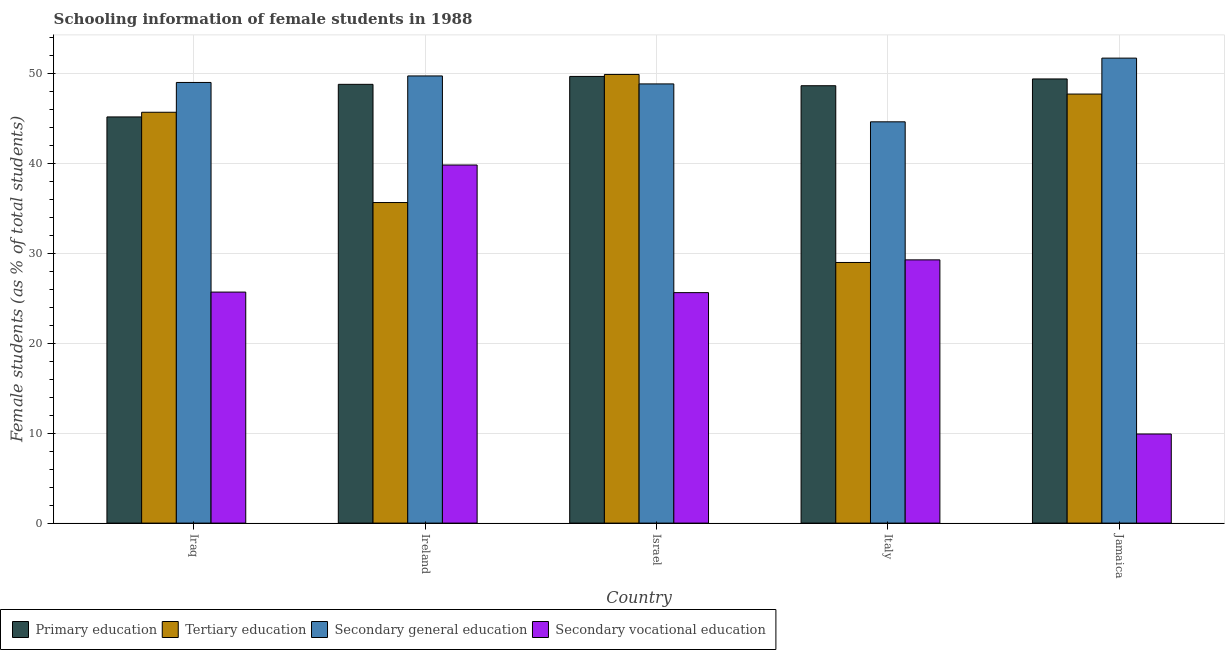How many different coloured bars are there?
Provide a succinct answer. 4. How many groups of bars are there?
Ensure brevity in your answer.  5. Are the number of bars on each tick of the X-axis equal?
Make the answer very short. Yes. How many bars are there on the 3rd tick from the left?
Provide a succinct answer. 4. What is the label of the 5th group of bars from the left?
Offer a very short reply. Jamaica. What is the percentage of female students in primary education in Jamaica?
Keep it short and to the point. 49.35. Across all countries, what is the maximum percentage of female students in secondary education?
Ensure brevity in your answer.  51.67. Across all countries, what is the minimum percentage of female students in secondary vocational education?
Offer a terse response. 9.9. In which country was the percentage of female students in secondary education maximum?
Your answer should be compact. Jamaica. In which country was the percentage of female students in tertiary education minimum?
Give a very brief answer. Italy. What is the total percentage of female students in primary education in the graph?
Make the answer very short. 241.47. What is the difference between the percentage of female students in secondary education in Iraq and that in Israel?
Offer a very short reply. 0.16. What is the difference between the percentage of female students in secondary education in Iraq and the percentage of female students in tertiary education in Jamaica?
Your answer should be very brief. 1.29. What is the average percentage of female students in tertiary education per country?
Offer a terse response. 41.55. What is the difference between the percentage of female students in secondary vocational education and percentage of female students in primary education in Iraq?
Offer a terse response. -19.46. In how many countries, is the percentage of female students in primary education greater than 18 %?
Your answer should be compact. 5. What is the ratio of the percentage of female students in tertiary education in Iraq to that in Jamaica?
Your answer should be very brief. 0.96. Is the percentage of female students in primary education in Iraq less than that in Israel?
Offer a terse response. Yes. Is the difference between the percentage of female students in secondary vocational education in Iraq and Israel greater than the difference between the percentage of female students in secondary education in Iraq and Israel?
Offer a very short reply. No. What is the difference between the highest and the second highest percentage of female students in secondary vocational education?
Ensure brevity in your answer.  10.54. What is the difference between the highest and the lowest percentage of female students in secondary education?
Give a very brief answer. 7.08. Is the sum of the percentage of female students in secondary vocational education in Israel and Italy greater than the maximum percentage of female students in tertiary education across all countries?
Keep it short and to the point. Yes. What does the 3rd bar from the left in Italy represents?
Offer a very short reply. Secondary general education. What does the 3rd bar from the right in Italy represents?
Provide a succinct answer. Tertiary education. Is it the case that in every country, the sum of the percentage of female students in primary education and percentage of female students in tertiary education is greater than the percentage of female students in secondary education?
Provide a short and direct response. Yes. Are all the bars in the graph horizontal?
Your answer should be compact. No. What is the difference between two consecutive major ticks on the Y-axis?
Provide a short and direct response. 10. Are the values on the major ticks of Y-axis written in scientific E-notation?
Keep it short and to the point. No. How many legend labels are there?
Your answer should be very brief. 4. How are the legend labels stacked?
Provide a short and direct response. Horizontal. What is the title of the graph?
Your response must be concise. Schooling information of female students in 1988. Does "Social Insurance" appear as one of the legend labels in the graph?
Provide a short and direct response. No. What is the label or title of the X-axis?
Your answer should be very brief. Country. What is the label or title of the Y-axis?
Provide a succinct answer. Female students (as % of total students). What is the Female students (as % of total students) in Primary education in Iraq?
Keep it short and to the point. 45.13. What is the Female students (as % of total students) in Tertiary education in Iraq?
Offer a terse response. 45.65. What is the Female students (as % of total students) in Secondary general education in Iraq?
Offer a very short reply. 48.96. What is the Female students (as % of total students) of Secondary vocational education in Iraq?
Provide a succinct answer. 25.67. What is the Female students (as % of total students) in Primary education in Ireland?
Give a very brief answer. 48.75. What is the Female students (as % of total students) in Tertiary education in Ireland?
Offer a terse response. 35.62. What is the Female students (as % of total students) of Secondary general education in Ireland?
Keep it short and to the point. 49.69. What is the Female students (as % of total students) in Secondary vocational education in Ireland?
Give a very brief answer. 39.79. What is the Female students (as % of total students) in Primary education in Israel?
Make the answer very short. 49.63. What is the Female students (as % of total students) in Tertiary education in Israel?
Provide a succinct answer. 49.85. What is the Female students (as % of total students) in Secondary general education in Israel?
Make the answer very short. 48.8. What is the Female students (as % of total students) of Secondary vocational education in Israel?
Offer a very short reply. 25.61. What is the Female students (as % of total students) in Primary education in Italy?
Ensure brevity in your answer.  48.6. What is the Female students (as % of total students) in Tertiary education in Italy?
Your response must be concise. 28.96. What is the Female students (as % of total students) of Secondary general education in Italy?
Provide a short and direct response. 44.59. What is the Female students (as % of total students) of Secondary vocational education in Italy?
Keep it short and to the point. 29.25. What is the Female students (as % of total students) in Primary education in Jamaica?
Make the answer very short. 49.35. What is the Female students (as % of total students) in Tertiary education in Jamaica?
Your answer should be compact. 47.67. What is the Female students (as % of total students) of Secondary general education in Jamaica?
Keep it short and to the point. 51.67. What is the Female students (as % of total students) in Secondary vocational education in Jamaica?
Keep it short and to the point. 9.9. Across all countries, what is the maximum Female students (as % of total students) of Primary education?
Your answer should be very brief. 49.63. Across all countries, what is the maximum Female students (as % of total students) of Tertiary education?
Provide a short and direct response. 49.85. Across all countries, what is the maximum Female students (as % of total students) in Secondary general education?
Give a very brief answer. 51.67. Across all countries, what is the maximum Female students (as % of total students) in Secondary vocational education?
Your answer should be very brief. 39.79. Across all countries, what is the minimum Female students (as % of total students) of Primary education?
Make the answer very short. 45.13. Across all countries, what is the minimum Female students (as % of total students) of Tertiary education?
Ensure brevity in your answer.  28.96. Across all countries, what is the minimum Female students (as % of total students) of Secondary general education?
Make the answer very short. 44.59. Across all countries, what is the minimum Female students (as % of total students) in Secondary vocational education?
Ensure brevity in your answer.  9.9. What is the total Female students (as % of total students) of Primary education in the graph?
Keep it short and to the point. 241.47. What is the total Female students (as % of total students) of Tertiary education in the graph?
Your response must be concise. 207.76. What is the total Female students (as % of total students) of Secondary general education in the graph?
Keep it short and to the point. 243.7. What is the total Female students (as % of total students) of Secondary vocational education in the graph?
Make the answer very short. 130.22. What is the difference between the Female students (as % of total students) of Primary education in Iraq and that in Ireland?
Ensure brevity in your answer.  -3.62. What is the difference between the Female students (as % of total students) in Tertiary education in Iraq and that in Ireland?
Keep it short and to the point. 10.03. What is the difference between the Female students (as % of total students) of Secondary general education in Iraq and that in Ireland?
Make the answer very short. -0.72. What is the difference between the Female students (as % of total students) in Secondary vocational education in Iraq and that in Ireland?
Offer a very short reply. -14.12. What is the difference between the Female students (as % of total students) in Primary education in Iraq and that in Israel?
Your response must be concise. -4.5. What is the difference between the Female students (as % of total students) of Tertiary education in Iraq and that in Israel?
Keep it short and to the point. -4.2. What is the difference between the Female students (as % of total students) in Secondary general education in Iraq and that in Israel?
Give a very brief answer. 0.16. What is the difference between the Female students (as % of total students) of Secondary vocational education in Iraq and that in Israel?
Offer a very short reply. 0.06. What is the difference between the Female students (as % of total students) of Primary education in Iraq and that in Italy?
Give a very brief answer. -3.47. What is the difference between the Female students (as % of total students) of Tertiary education in Iraq and that in Italy?
Your answer should be very brief. 16.69. What is the difference between the Female students (as % of total students) in Secondary general education in Iraq and that in Italy?
Keep it short and to the point. 4.37. What is the difference between the Female students (as % of total students) of Secondary vocational education in Iraq and that in Italy?
Your response must be concise. -3.58. What is the difference between the Female students (as % of total students) in Primary education in Iraq and that in Jamaica?
Keep it short and to the point. -4.22. What is the difference between the Female students (as % of total students) in Tertiary education in Iraq and that in Jamaica?
Make the answer very short. -2.02. What is the difference between the Female students (as % of total students) in Secondary general education in Iraq and that in Jamaica?
Make the answer very short. -2.7. What is the difference between the Female students (as % of total students) of Secondary vocational education in Iraq and that in Jamaica?
Make the answer very short. 15.77. What is the difference between the Female students (as % of total students) of Primary education in Ireland and that in Israel?
Provide a short and direct response. -0.88. What is the difference between the Female students (as % of total students) in Tertiary education in Ireland and that in Israel?
Your answer should be very brief. -14.23. What is the difference between the Female students (as % of total students) of Secondary general education in Ireland and that in Israel?
Your answer should be compact. 0.89. What is the difference between the Female students (as % of total students) of Secondary vocational education in Ireland and that in Israel?
Provide a short and direct response. 14.18. What is the difference between the Female students (as % of total students) in Primary education in Ireland and that in Italy?
Your response must be concise. 0.15. What is the difference between the Female students (as % of total students) of Tertiary education in Ireland and that in Italy?
Your response must be concise. 6.66. What is the difference between the Female students (as % of total students) in Secondary general education in Ireland and that in Italy?
Give a very brief answer. 5.1. What is the difference between the Female students (as % of total students) of Secondary vocational education in Ireland and that in Italy?
Your answer should be compact. 10.54. What is the difference between the Female students (as % of total students) of Primary education in Ireland and that in Jamaica?
Provide a succinct answer. -0.6. What is the difference between the Female students (as % of total students) in Tertiary education in Ireland and that in Jamaica?
Ensure brevity in your answer.  -12.06. What is the difference between the Female students (as % of total students) of Secondary general education in Ireland and that in Jamaica?
Your response must be concise. -1.98. What is the difference between the Female students (as % of total students) in Secondary vocational education in Ireland and that in Jamaica?
Provide a short and direct response. 29.89. What is the difference between the Female students (as % of total students) in Tertiary education in Israel and that in Italy?
Ensure brevity in your answer.  20.89. What is the difference between the Female students (as % of total students) in Secondary general education in Israel and that in Italy?
Your response must be concise. 4.21. What is the difference between the Female students (as % of total students) in Secondary vocational education in Israel and that in Italy?
Keep it short and to the point. -3.64. What is the difference between the Female students (as % of total students) in Primary education in Israel and that in Jamaica?
Provide a short and direct response. 0.28. What is the difference between the Female students (as % of total students) of Tertiary education in Israel and that in Jamaica?
Your response must be concise. 2.18. What is the difference between the Female students (as % of total students) in Secondary general education in Israel and that in Jamaica?
Your response must be concise. -2.87. What is the difference between the Female students (as % of total students) of Secondary vocational education in Israel and that in Jamaica?
Your answer should be compact. 15.71. What is the difference between the Female students (as % of total students) of Primary education in Italy and that in Jamaica?
Offer a very short reply. -0.75. What is the difference between the Female students (as % of total students) in Tertiary education in Italy and that in Jamaica?
Offer a very short reply. -18.71. What is the difference between the Female students (as % of total students) of Secondary general education in Italy and that in Jamaica?
Offer a terse response. -7.08. What is the difference between the Female students (as % of total students) of Secondary vocational education in Italy and that in Jamaica?
Your answer should be very brief. 19.35. What is the difference between the Female students (as % of total students) of Primary education in Iraq and the Female students (as % of total students) of Tertiary education in Ireland?
Your answer should be very brief. 9.51. What is the difference between the Female students (as % of total students) in Primary education in Iraq and the Female students (as % of total students) in Secondary general education in Ireland?
Make the answer very short. -4.55. What is the difference between the Female students (as % of total students) of Primary education in Iraq and the Female students (as % of total students) of Secondary vocational education in Ireland?
Offer a very short reply. 5.34. What is the difference between the Female students (as % of total students) of Tertiary education in Iraq and the Female students (as % of total students) of Secondary general education in Ireland?
Your answer should be compact. -4.04. What is the difference between the Female students (as % of total students) in Tertiary education in Iraq and the Female students (as % of total students) in Secondary vocational education in Ireland?
Keep it short and to the point. 5.86. What is the difference between the Female students (as % of total students) in Secondary general education in Iraq and the Female students (as % of total students) in Secondary vocational education in Ireland?
Make the answer very short. 9.17. What is the difference between the Female students (as % of total students) of Primary education in Iraq and the Female students (as % of total students) of Tertiary education in Israel?
Provide a succinct answer. -4.72. What is the difference between the Female students (as % of total students) in Primary education in Iraq and the Female students (as % of total students) in Secondary general education in Israel?
Offer a very short reply. -3.67. What is the difference between the Female students (as % of total students) of Primary education in Iraq and the Female students (as % of total students) of Secondary vocational education in Israel?
Offer a terse response. 19.52. What is the difference between the Female students (as % of total students) in Tertiary education in Iraq and the Female students (as % of total students) in Secondary general education in Israel?
Offer a very short reply. -3.15. What is the difference between the Female students (as % of total students) in Tertiary education in Iraq and the Female students (as % of total students) in Secondary vocational education in Israel?
Offer a very short reply. 20.04. What is the difference between the Female students (as % of total students) in Secondary general education in Iraq and the Female students (as % of total students) in Secondary vocational education in Israel?
Make the answer very short. 23.35. What is the difference between the Female students (as % of total students) in Primary education in Iraq and the Female students (as % of total students) in Tertiary education in Italy?
Offer a terse response. 16.17. What is the difference between the Female students (as % of total students) in Primary education in Iraq and the Female students (as % of total students) in Secondary general education in Italy?
Provide a succinct answer. 0.54. What is the difference between the Female students (as % of total students) of Primary education in Iraq and the Female students (as % of total students) of Secondary vocational education in Italy?
Offer a terse response. 15.88. What is the difference between the Female students (as % of total students) in Tertiary education in Iraq and the Female students (as % of total students) in Secondary general education in Italy?
Your answer should be very brief. 1.06. What is the difference between the Female students (as % of total students) in Tertiary education in Iraq and the Female students (as % of total students) in Secondary vocational education in Italy?
Ensure brevity in your answer.  16.4. What is the difference between the Female students (as % of total students) in Secondary general education in Iraq and the Female students (as % of total students) in Secondary vocational education in Italy?
Your response must be concise. 19.71. What is the difference between the Female students (as % of total students) of Primary education in Iraq and the Female students (as % of total students) of Tertiary education in Jamaica?
Your answer should be very brief. -2.54. What is the difference between the Female students (as % of total students) of Primary education in Iraq and the Female students (as % of total students) of Secondary general education in Jamaica?
Give a very brief answer. -6.53. What is the difference between the Female students (as % of total students) of Primary education in Iraq and the Female students (as % of total students) of Secondary vocational education in Jamaica?
Offer a terse response. 35.23. What is the difference between the Female students (as % of total students) in Tertiary education in Iraq and the Female students (as % of total students) in Secondary general education in Jamaica?
Offer a very short reply. -6.01. What is the difference between the Female students (as % of total students) in Tertiary education in Iraq and the Female students (as % of total students) in Secondary vocational education in Jamaica?
Ensure brevity in your answer.  35.75. What is the difference between the Female students (as % of total students) of Secondary general education in Iraq and the Female students (as % of total students) of Secondary vocational education in Jamaica?
Your answer should be very brief. 39.06. What is the difference between the Female students (as % of total students) in Primary education in Ireland and the Female students (as % of total students) in Tertiary education in Israel?
Offer a terse response. -1.1. What is the difference between the Female students (as % of total students) of Primary education in Ireland and the Female students (as % of total students) of Secondary general education in Israel?
Offer a very short reply. -0.05. What is the difference between the Female students (as % of total students) of Primary education in Ireland and the Female students (as % of total students) of Secondary vocational education in Israel?
Make the answer very short. 23.14. What is the difference between the Female students (as % of total students) of Tertiary education in Ireland and the Female students (as % of total students) of Secondary general education in Israel?
Your answer should be very brief. -13.18. What is the difference between the Female students (as % of total students) of Tertiary education in Ireland and the Female students (as % of total students) of Secondary vocational education in Israel?
Your answer should be very brief. 10.01. What is the difference between the Female students (as % of total students) of Secondary general education in Ireland and the Female students (as % of total students) of Secondary vocational education in Israel?
Keep it short and to the point. 24.08. What is the difference between the Female students (as % of total students) of Primary education in Ireland and the Female students (as % of total students) of Tertiary education in Italy?
Your answer should be very brief. 19.79. What is the difference between the Female students (as % of total students) in Primary education in Ireland and the Female students (as % of total students) in Secondary general education in Italy?
Your response must be concise. 4.16. What is the difference between the Female students (as % of total students) in Primary education in Ireland and the Female students (as % of total students) in Secondary vocational education in Italy?
Your answer should be very brief. 19.5. What is the difference between the Female students (as % of total students) of Tertiary education in Ireland and the Female students (as % of total students) of Secondary general education in Italy?
Make the answer very short. -8.97. What is the difference between the Female students (as % of total students) in Tertiary education in Ireland and the Female students (as % of total students) in Secondary vocational education in Italy?
Your response must be concise. 6.37. What is the difference between the Female students (as % of total students) in Secondary general education in Ireland and the Female students (as % of total students) in Secondary vocational education in Italy?
Your answer should be very brief. 20.44. What is the difference between the Female students (as % of total students) in Primary education in Ireland and the Female students (as % of total students) in Tertiary education in Jamaica?
Your answer should be compact. 1.08. What is the difference between the Female students (as % of total students) in Primary education in Ireland and the Female students (as % of total students) in Secondary general education in Jamaica?
Your response must be concise. -2.91. What is the difference between the Female students (as % of total students) of Primary education in Ireland and the Female students (as % of total students) of Secondary vocational education in Jamaica?
Your response must be concise. 38.85. What is the difference between the Female students (as % of total students) in Tertiary education in Ireland and the Female students (as % of total students) in Secondary general education in Jamaica?
Offer a very short reply. -16.05. What is the difference between the Female students (as % of total students) of Tertiary education in Ireland and the Female students (as % of total students) of Secondary vocational education in Jamaica?
Offer a terse response. 25.72. What is the difference between the Female students (as % of total students) of Secondary general education in Ireland and the Female students (as % of total students) of Secondary vocational education in Jamaica?
Provide a succinct answer. 39.78. What is the difference between the Female students (as % of total students) in Primary education in Israel and the Female students (as % of total students) in Tertiary education in Italy?
Provide a succinct answer. 20.67. What is the difference between the Female students (as % of total students) of Primary education in Israel and the Female students (as % of total students) of Secondary general education in Italy?
Your response must be concise. 5.04. What is the difference between the Female students (as % of total students) in Primary education in Israel and the Female students (as % of total students) in Secondary vocational education in Italy?
Your answer should be very brief. 20.38. What is the difference between the Female students (as % of total students) of Tertiary education in Israel and the Female students (as % of total students) of Secondary general education in Italy?
Offer a very short reply. 5.26. What is the difference between the Female students (as % of total students) of Tertiary education in Israel and the Female students (as % of total students) of Secondary vocational education in Italy?
Keep it short and to the point. 20.6. What is the difference between the Female students (as % of total students) in Secondary general education in Israel and the Female students (as % of total students) in Secondary vocational education in Italy?
Your answer should be very brief. 19.55. What is the difference between the Female students (as % of total students) of Primary education in Israel and the Female students (as % of total students) of Tertiary education in Jamaica?
Provide a succinct answer. 1.96. What is the difference between the Female students (as % of total students) of Primary education in Israel and the Female students (as % of total students) of Secondary general education in Jamaica?
Your answer should be compact. -2.03. What is the difference between the Female students (as % of total students) in Primary education in Israel and the Female students (as % of total students) in Secondary vocational education in Jamaica?
Ensure brevity in your answer.  39.73. What is the difference between the Female students (as % of total students) of Tertiary education in Israel and the Female students (as % of total students) of Secondary general education in Jamaica?
Your answer should be very brief. -1.81. What is the difference between the Female students (as % of total students) in Tertiary education in Israel and the Female students (as % of total students) in Secondary vocational education in Jamaica?
Provide a succinct answer. 39.95. What is the difference between the Female students (as % of total students) in Secondary general education in Israel and the Female students (as % of total students) in Secondary vocational education in Jamaica?
Your answer should be compact. 38.9. What is the difference between the Female students (as % of total students) of Primary education in Italy and the Female students (as % of total students) of Tertiary education in Jamaica?
Your answer should be very brief. 0.92. What is the difference between the Female students (as % of total students) of Primary education in Italy and the Female students (as % of total students) of Secondary general education in Jamaica?
Give a very brief answer. -3.07. What is the difference between the Female students (as % of total students) in Primary education in Italy and the Female students (as % of total students) in Secondary vocational education in Jamaica?
Your response must be concise. 38.7. What is the difference between the Female students (as % of total students) of Tertiary education in Italy and the Female students (as % of total students) of Secondary general education in Jamaica?
Give a very brief answer. -22.71. What is the difference between the Female students (as % of total students) of Tertiary education in Italy and the Female students (as % of total students) of Secondary vocational education in Jamaica?
Provide a short and direct response. 19.06. What is the difference between the Female students (as % of total students) in Secondary general education in Italy and the Female students (as % of total students) in Secondary vocational education in Jamaica?
Your response must be concise. 34.69. What is the average Female students (as % of total students) in Primary education per country?
Your answer should be compact. 48.29. What is the average Female students (as % of total students) of Tertiary education per country?
Ensure brevity in your answer.  41.55. What is the average Female students (as % of total students) in Secondary general education per country?
Offer a very short reply. 48.74. What is the average Female students (as % of total students) of Secondary vocational education per country?
Provide a succinct answer. 26.04. What is the difference between the Female students (as % of total students) of Primary education and Female students (as % of total students) of Tertiary education in Iraq?
Give a very brief answer. -0.52. What is the difference between the Female students (as % of total students) of Primary education and Female students (as % of total students) of Secondary general education in Iraq?
Keep it short and to the point. -3.83. What is the difference between the Female students (as % of total students) in Primary education and Female students (as % of total students) in Secondary vocational education in Iraq?
Offer a terse response. 19.46. What is the difference between the Female students (as % of total students) of Tertiary education and Female students (as % of total students) of Secondary general education in Iraq?
Offer a very short reply. -3.31. What is the difference between the Female students (as % of total students) of Tertiary education and Female students (as % of total students) of Secondary vocational education in Iraq?
Offer a very short reply. 19.98. What is the difference between the Female students (as % of total students) of Secondary general education and Female students (as % of total students) of Secondary vocational education in Iraq?
Make the answer very short. 23.29. What is the difference between the Female students (as % of total students) in Primary education and Female students (as % of total students) in Tertiary education in Ireland?
Provide a short and direct response. 13.13. What is the difference between the Female students (as % of total students) of Primary education and Female students (as % of total students) of Secondary general education in Ireland?
Ensure brevity in your answer.  -0.93. What is the difference between the Female students (as % of total students) in Primary education and Female students (as % of total students) in Secondary vocational education in Ireland?
Ensure brevity in your answer.  8.96. What is the difference between the Female students (as % of total students) of Tertiary education and Female students (as % of total students) of Secondary general education in Ireland?
Offer a very short reply. -14.07. What is the difference between the Female students (as % of total students) in Tertiary education and Female students (as % of total students) in Secondary vocational education in Ireland?
Your response must be concise. -4.17. What is the difference between the Female students (as % of total students) of Secondary general education and Female students (as % of total students) of Secondary vocational education in Ireland?
Your response must be concise. 9.9. What is the difference between the Female students (as % of total students) in Primary education and Female students (as % of total students) in Tertiary education in Israel?
Ensure brevity in your answer.  -0.22. What is the difference between the Female students (as % of total students) in Primary education and Female students (as % of total students) in Secondary general education in Israel?
Provide a short and direct response. 0.83. What is the difference between the Female students (as % of total students) in Primary education and Female students (as % of total students) in Secondary vocational education in Israel?
Your answer should be compact. 24.02. What is the difference between the Female students (as % of total students) in Tertiary education and Female students (as % of total students) in Secondary general education in Israel?
Make the answer very short. 1.05. What is the difference between the Female students (as % of total students) in Tertiary education and Female students (as % of total students) in Secondary vocational education in Israel?
Your answer should be very brief. 24.24. What is the difference between the Female students (as % of total students) of Secondary general education and Female students (as % of total students) of Secondary vocational education in Israel?
Ensure brevity in your answer.  23.19. What is the difference between the Female students (as % of total students) in Primary education and Female students (as % of total students) in Tertiary education in Italy?
Offer a terse response. 19.64. What is the difference between the Female students (as % of total students) in Primary education and Female students (as % of total students) in Secondary general education in Italy?
Provide a succinct answer. 4.01. What is the difference between the Female students (as % of total students) of Primary education and Female students (as % of total students) of Secondary vocational education in Italy?
Ensure brevity in your answer.  19.35. What is the difference between the Female students (as % of total students) of Tertiary education and Female students (as % of total students) of Secondary general education in Italy?
Give a very brief answer. -15.63. What is the difference between the Female students (as % of total students) in Tertiary education and Female students (as % of total students) in Secondary vocational education in Italy?
Make the answer very short. -0.29. What is the difference between the Female students (as % of total students) in Secondary general education and Female students (as % of total students) in Secondary vocational education in Italy?
Provide a succinct answer. 15.34. What is the difference between the Female students (as % of total students) in Primary education and Female students (as % of total students) in Tertiary education in Jamaica?
Keep it short and to the point. 1.68. What is the difference between the Female students (as % of total students) in Primary education and Female students (as % of total students) in Secondary general education in Jamaica?
Ensure brevity in your answer.  -2.31. What is the difference between the Female students (as % of total students) of Primary education and Female students (as % of total students) of Secondary vocational education in Jamaica?
Offer a very short reply. 39.45. What is the difference between the Female students (as % of total students) in Tertiary education and Female students (as % of total students) in Secondary general education in Jamaica?
Ensure brevity in your answer.  -3.99. What is the difference between the Female students (as % of total students) in Tertiary education and Female students (as % of total students) in Secondary vocational education in Jamaica?
Your answer should be compact. 37.77. What is the difference between the Female students (as % of total students) in Secondary general education and Female students (as % of total students) in Secondary vocational education in Jamaica?
Provide a short and direct response. 41.76. What is the ratio of the Female students (as % of total students) of Primary education in Iraq to that in Ireland?
Keep it short and to the point. 0.93. What is the ratio of the Female students (as % of total students) of Tertiary education in Iraq to that in Ireland?
Offer a very short reply. 1.28. What is the ratio of the Female students (as % of total students) of Secondary general education in Iraq to that in Ireland?
Provide a short and direct response. 0.99. What is the ratio of the Female students (as % of total students) of Secondary vocational education in Iraq to that in Ireland?
Ensure brevity in your answer.  0.65. What is the ratio of the Female students (as % of total students) of Primary education in Iraq to that in Israel?
Offer a very short reply. 0.91. What is the ratio of the Female students (as % of total students) in Tertiary education in Iraq to that in Israel?
Make the answer very short. 0.92. What is the ratio of the Female students (as % of total students) of Secondary general education in Iraq to that in Israel?
Your answer should be very brief. 1. What is the ratio of the Female students (as % of total students) of Primary education in Iraq to that in Italy?
Give a very brief answer. 0.93. What is the ratio of the Female students (as % of total students) in Tertiary education in Iraq to that in Italy?
Keep it short and to the point. 1.58. What is the ratio of the Female students (as % of total students) in Secondary general education in Iraq to that in Italy?
Make the answer very short. 1.1. What is the ratio of the Female students (as % of total students) in Secondary vocational education in Iraq to that in Italy?
Ensure brevity in your answer.  0.88. What is the ratio of the Female students (as % of total students) in Primary education in Iraq to that in Jamaica?
Keep it short and to the point. 0.91. What is the ratio of the Female students (as % of total students) of Tertiary education in Iraq to that in Jamaica?
Offer a terse response. 0.96. What is the ratio of the Female students (as % of total students) of Secondary general education in Iraq to that in Jamaica?
Offer a very short reply. 0.95. What is the ratio of the Female students (as % of total students) of Secondary vocational education in Iraq to that in Jamaica?
Your response must be concise. 2.59. What is the ratio of the Female students (as % of total students) of Primary education in Ireland to that in Israel?
Give a very brief answer. 0.98. What is the ratio of the Female students (as % of total students) of Tertiary education in Ireland to that in Israel?
Make the answer very short. 0.71. What is the ratio of the Female students (as % of total students) of Secondary general education in Ireland to that in Israel?
Give a very brief answer. 1.02. What is the ratio of the Female students (as % of total students) in Secondary vocational education in Ireland to that in Israel?
Your answer should be very brief. 1.55. What is the ratio of the Female students (as % of total students) of Tertiary education in Ireland to that in Italy?
Your answer should be compact. 1.23. What is the ratio of the Female students (as % of total students) of Secondary general education in Ireland to that in Italy?
Your answer should be compact. 1.11. What is the ratio of the Female students (as % of total students) of Secondary vocational education in Ireland to that in Italy?
Provide a succinct answer. 1.36. What is the ratio of the Female students (as % of total students) in Primary education in Ireland to that in Jamaica?
Make the answer very short. 0.99. What is the ratio of the Female students (as % of total students) of Tertiary education in Ireland to that in Jamaica?
Keep it short and to the point. 0.75. What is the ratio of the Female students (as % of total students) of Secondary general education in Ireland to that in Jamaica?
Your answer should be very brief. 0.96. What is the ratio of the Female students (as % of total students) of Secondary vocational education in Ireland to that in Jamaica?
Ensure brevity in your answer.  4.02. What is the ratio of the Female students (as % of total students) in Primary education in Israel to that in Italy?
Offer a very short reply. 1.02. What is the ratio of the Female students (as % of total students) of Tertiary education in Israel to that in Italy?
Your answer should be compact. 1.72. What is the ratio of the Female students (as % of total students) of Secondary general education in Israel to that in Italy?
Keep it short and to the point. 1.09. What is the ratio of the Female students (as % of total students) of Secondary vocational education in Israel to that in Italy?
Ensure brevity in your answer.  0.88. What is the ratio of the Female students (as % of total students) in Tertiary education in Israel to that in Jamaica?
Offer a terse response. 1.05. What is the ratio of the Female students (as % of total students) in Secondary general education in Israel to that in Jamaica?
Keep it short and to the point. 0.94. What is the ratio of the Female students (as % of total students) in Secondary vocational education in Israel to that in Jamaica?
Offer a terse response. 2.59. What is the ratio of the Female students (as % of total students) of Primary education in Italy to that in Jamaica?
Offer a terse response. 0.98. What is the ratio of the Female students (as % of total students) of Tertiary education in Italy to that in Jamaica?
Your answer should be compact. 0.61. What is the ratio of the Female students (as % of total students) in Secondary general education in Italy to that in Jamaica?
Provide a short and direct response. 0.86. What is the ratio of the Female students (as % of total students) in Secondary vocational education in Italy to that in Jamaica?
Provide a succinct answer. 2.95. What is the difference between the highest and the second highest Female students (as % of total students) in Primary education?
Your answer should be compact. 0.28. What is the difference between the highest and the second highest Female students (as % of total students) in Tertiary education?
Your answer should be very brief. 2.18. What is the difference between the highest and the second highest Female students (as % of total students) in Secondary general education?
Offer a terse response. 1.98. What is the difference between the highest and the second highest Female students (as % of total students) of Secondary vocational education?
Your answer should be very brief. 10.54. What is the difference between the highest and the lowest Female students (as % of total students) of Primary education?
Keep it short and to the point. 4.5. What is the difference between the highest and the lowest Female students (as % of total students) in Tertiary education?
Give a very brief answer. 20.89. What is the difference between the highest and the lowest Female students (as % of total students) in Secondary general education?
Provide a short and direct response. 7.08. What is the difference between the highest and the lowest Female students (as % of total students) in Secondary vocational education?
Keep it short and to the point. 29.89. 